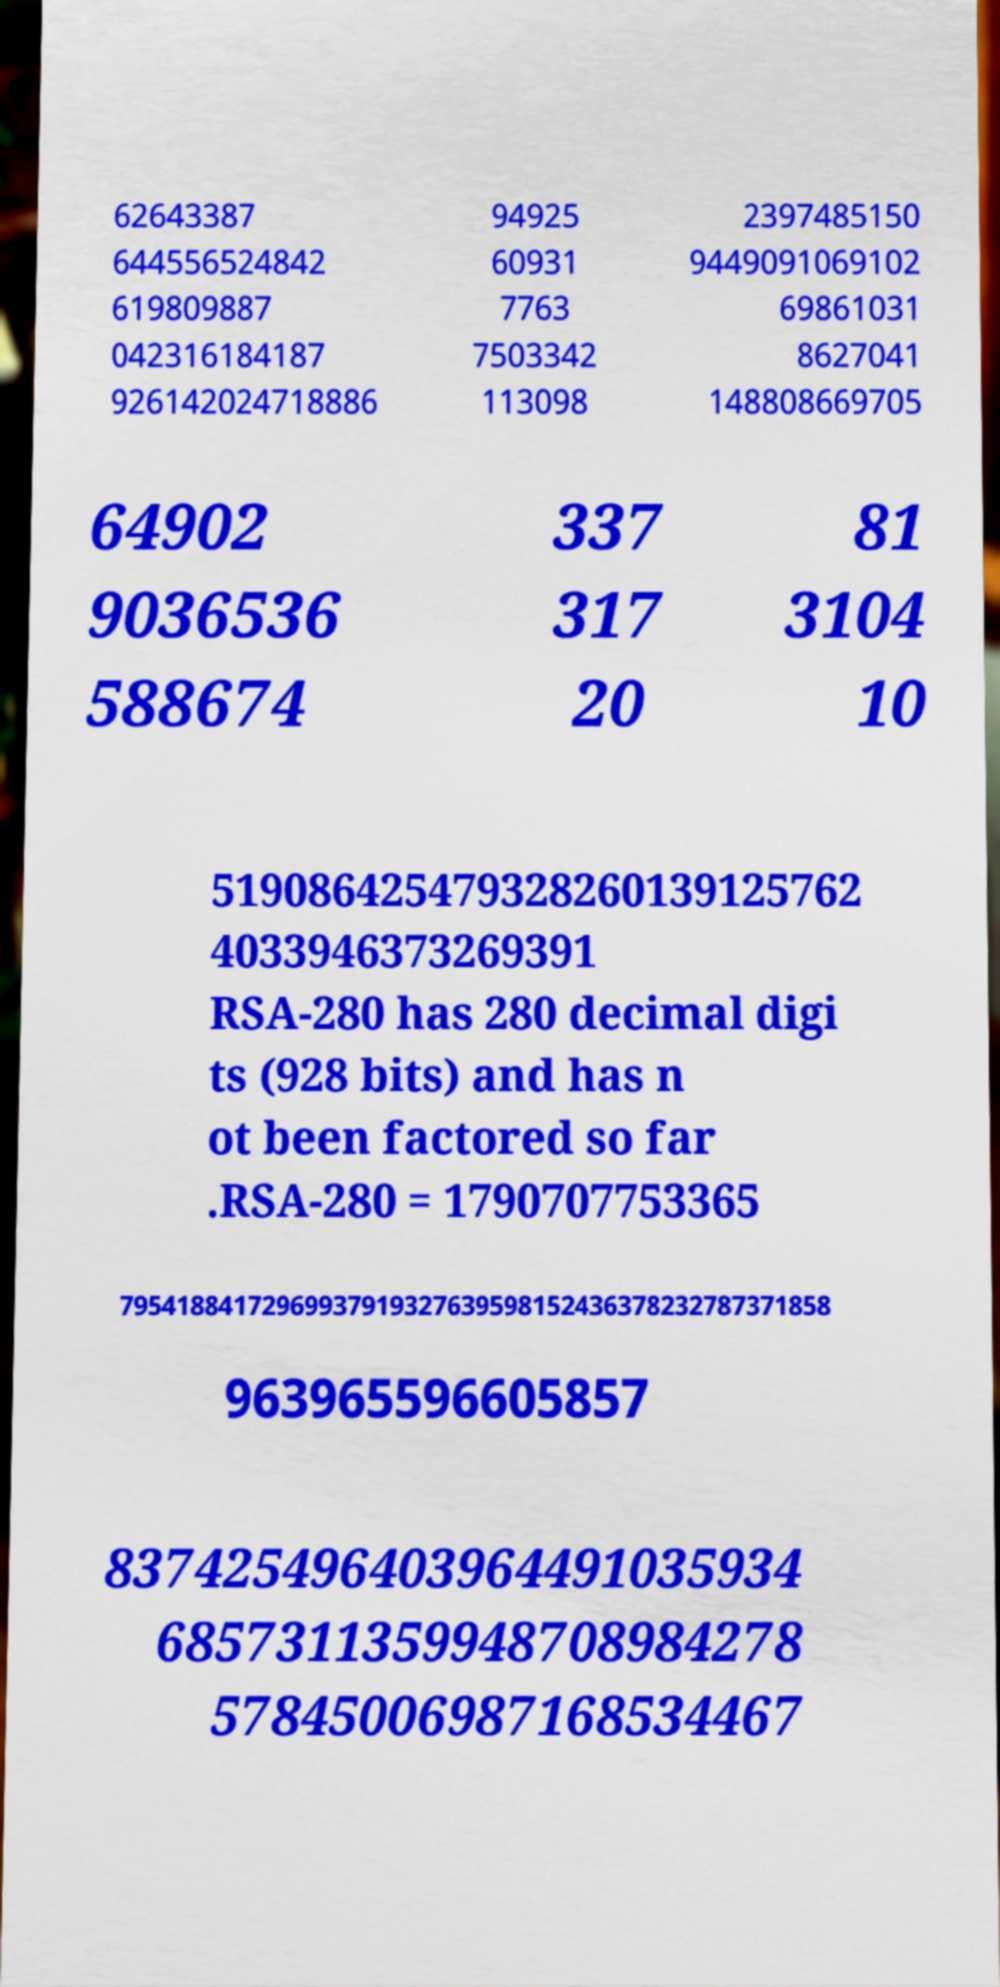Could you extract and type out the text from this image? 62643387 644556524842 619809887 042316184187 926142024718886 94925 60931 7763 7503342 113098 2397485150 9449091069102 69861031 8627041 148808669705 64902 9036536 588674 337 317 20 81 3104 10 519086425479328260139125762 4033946373269391 RSA-280 has 280 decimal digi ts (928 bits) and has n ot been factored so far .RSA-280 = 1790707753365 79541884172969937919327639598152436378232787371858 963965596605857 837425496403964491035934 6857311359948708984278 57845006987168534467 